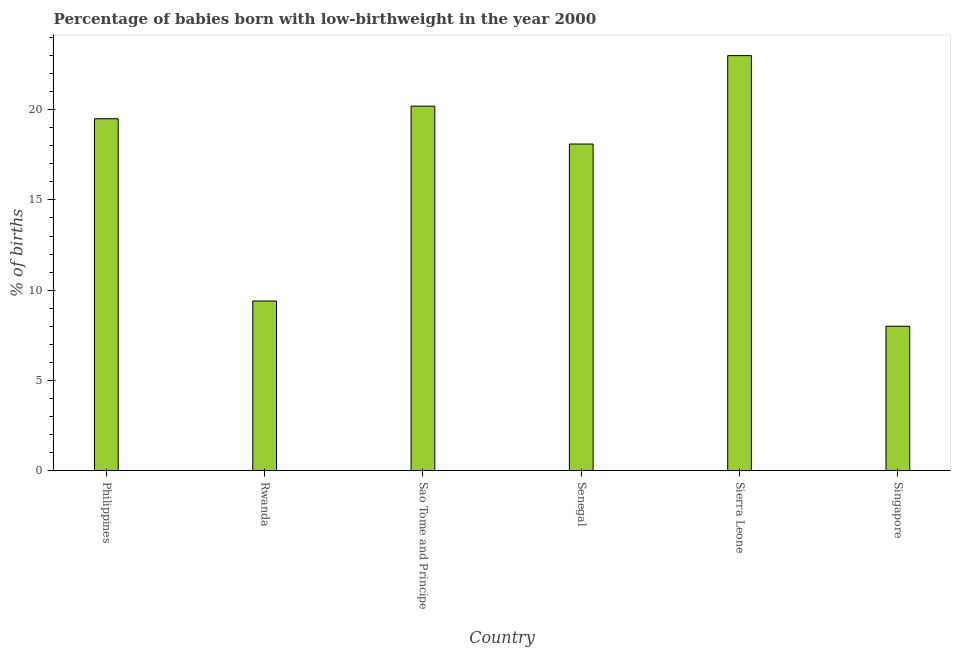Does the graph contain any zero values?
Your answer should be very brief. No. What is the title of the graph?
Ensure brevity in your answer.  Percentage of babies born with low-birthweight in the year 2000. What is the label or title of the Y-axis?
Give a very brief answer. % of births. Across all countries, what is the maximum percentage of babies who were born with low-birthweight?
Provide a succinct answer. 23. In which country was the percentage of babies who were born with low-birthweight maximum?
Offer a terse response. Sierra Leone. In which country was the percentage of babies who were born with low-birthweight minimum?
Keep it short and to the point. Singapore. What is the sum of the percentage of babies who were born with low-birthweight?
Ensure brevity in your answer.  98.2. What is the average percentage of babies who were born with low-birthweight per country?
Keep it short and to the point. 16.37. What is the median percentage of babies who were born with low-birthweight?
Provide a short and direct response. 18.8. What is the ratio of the percentage of babies who were born with low-birthweight in Philippines to that in Rwanda?
Your response must be concise. 2.07. Is the percentage of babies who were born with low-birthweight in Philippines less than that in Sierra Leone?
Offer a terse response. Yes. Is the difference between the percentage of babies who were born with low-birthweight in Philippines and Sao Tome and Principe greater than the difference between any two countries?
Provide a short and direct response. No. What is the difference between the highest and the second highest percentage of babies who were born with low-birthweight?
Provide a succinct answer. 2.8. Is the sum of the percentage of babies who were born with low-birthweight in Rwanda and Singapore greater than the maximum percentage of babies who were born with low-birthweight across all countries?
Offer a very short reply. No. In how many countries, is the percentage of babies who were born with low-birthweight greater than the average percentage of babies who were born with low-birthweight taken over all countries?
Your answer should be very brief. 4. How many bars are there?
Your answer should be compact. 6. How many countries are there in the graph?
Give a very brief answer. 6. What is the % of births of Philippines?
Make the answer very short. 19.5. What is the % of births of Sao Tome and Principe?
Offer a terse response. 20.2. What is the % of births of Senegal?
Your answer should be compact. 18.1. What is the % of births in Sierra Leone?
Keep it short and to the point. 23. What is the difference between the % of births in Philippines and Rwanda?
Offer a terse response. 10.1. What is the difference between the % of births in Philippines and Sao Tome and Principe?
Provide a succinct answer. -0.7. What is the difference between the % of births in Rwanda and Sao Tome and Principe?
Make the answer very short. -10.8. What is the difference between the % of births in Rwanda and Senegal?
Offer a terse response. -8.7. What is the difference between the % of births in Rwanda and Sierra Leone?
Provide a short and direct response. -13.6. What is the difference between the % of births in Rwanda and Singapore?
Your answer should be very brief. 1.4. What is the difference between the % of births in Sao Tome and Principe and Sierra Leone?
Provide a short and direct response. -2.8. What is the difference between the % of births in Senegal and Sierra Leone?
Make the answer very short. -4.9. What is the difference between the % of births in Senegal and Singapore?
Give a very brief answer. 10.1. What is the difference between the % of births in Sierra Leone and Singapore?
Provide a succinct answer. 15. What is the ratio of the % of births in Philippines to that in Rwanda?
Offer a very short reply. 2.07. What is the ratio of the % of births in Philippines to that in Senegal?
Offer a terse response. 1.08. What is the ratio of the % of births in Philippines to that in Sierra Leone?
Your answer should be compact. 0.85. What is the ratio of the % of births in Philippines to that in Singapore?
Offer a very short reply. 2.44. What is the ratio of the % of births in Rwanda to that in Sao Tome and Principe?
Your response must be concise. 0.47. What is the ratio of the % of births in Rwanda to that in Senegal?
Keep it short and to the point. 0.52. What is the ratio of the % of births in Rwanda to that in Sierra Leone?
Give a very brief answer. 0.41. What is the ratio of the % of births in Rwanda to that in Singapore?
Make the answer very short. 1.18. What is the ratio of the % of births in Sao Tome and Principe to that in Senegal?
Offer a terse response. 1.12. What is the ratio of the % of births in Sao Tome and Principe to that in Sierra Leone?
Your response must be concise. 0.88. What is the ratio of the % of births in Sao Tome and Principe to that in Singapore?
Keep it short and to the point. 2.52. What is the ratio of the % of births in Senegal to that in Sierra Leone?
Offer a very short reply. 0.79. What is the ratio of the % of births in Senegal to that in Singapore?
Make the answer very short. 2.26. What is the ratio of the % of births in Sierra Leone to that in Singapore?
Your answer should be very brief. 2.88. 